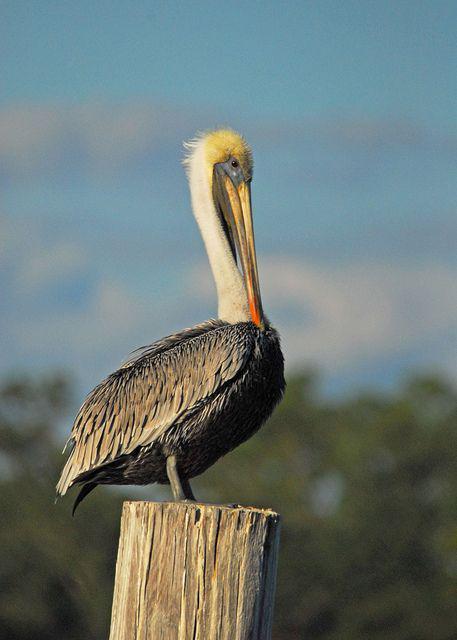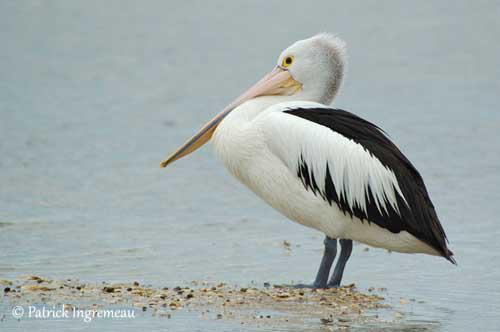The first image is the image on the left, the second image is the image on the right. Examine the images to the left and right. Is the description "An image shows a single gliding pelican with wings extended." accurate? Answer yes or no. No. 